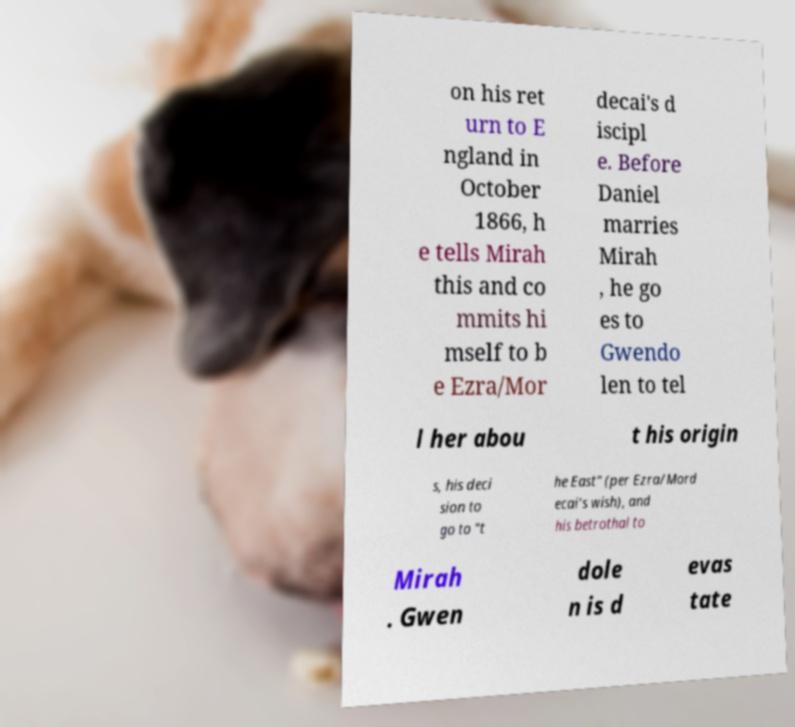I need the written content from this picture converted into text. Can you do that? on his ret urn to E ngland in October 1866, h e tells Mirah this and co mmits hi mself to b e Ezra/Mor decai's d iscipl e. Before Daniel marries Mirah , he go es to Gwendo len to tel l her abou t his origin s, his deci sion to go to "t he East" (per Ezra/Mord ecai's wish), and his betrothal to Mirah . Gwen dole n is d evas tate 